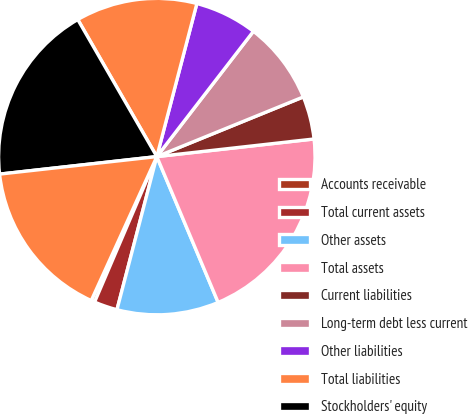<chart> <loc_0><loc_0><loc_500><loc_500><pie_chart><fcel>Accounts receivable<fcel>Total current assets<fcel>Other assets<fcel>Total assets<fcel>Current liabilities<fcel>Long-term debt less current<fcel>Other liabilities<fcel>Total liabilities<fcel>Stockholders' equity<fcel>Total equity<nl><fcel>0.37%<fcel>2.38%<fcel>10.39%<fcel>20.44%<fcel>4.38%<fcel>8.39%<fcel>6.38%<fcel>12.4%<fcel>18.44%<fcel>16.43%<nl></chart> 